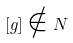Convert formula to latex. <formula><loc_0><loc_0><loc_500><loc_500>[ g ] \notin N</formula> 